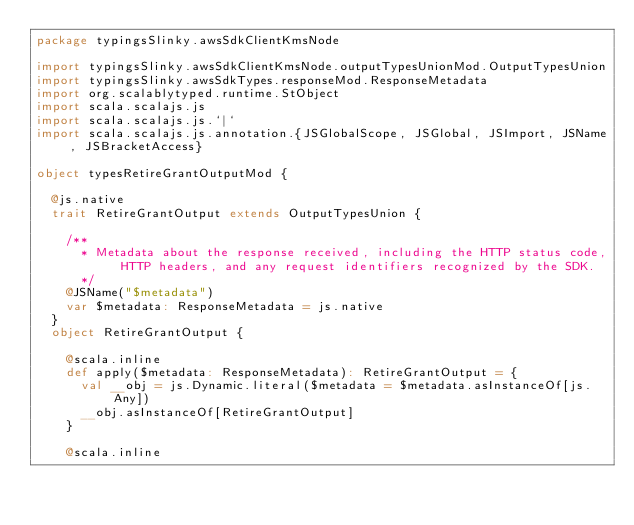<code> <loc_0><loc_0><loc_500><loc_500><_Scala_>package typingsSlinky.awsSdkClientKmsNode

import typingsSlinky.awsSdkClientKmsNode.outputTypesUnionMod.OutputTypesUnion
import typingsSlinky.awsSdkTypes.responseMod.ResponseMetadata
import org.scalablytyped.runtime.StObject
import scala.scalajs.js
import scala.scalajs.js.`|`
import scala.scalajs.js.annotation.{JSGlobalScope, JSGlobal, JSImport, JSName, JSBracketAccess}

object typesRetireGrantOutputMod {
  
  @js.native
  trait RetireGrantOutput extends OutputTypesUnion {
    
    /**
      * Metadata about the response received, including the HTTP status code, HTTP headers, and any request identifiers recognized by the SDK.
      */
    @JSName("$metadata")
    var $metadata: ResponseMetadata = js.native
  }
  object RetireGrantOutput {
    
    @scala.inline
    def apply($metadata: ResponseMetadata): RetireGrantOutput = {
      val __obj = js.Dynamic.literal($metadata = $metadata.asInstanceOf[js.Any])
      __obj.asInstanceOf[RetireGrantOutput]
    }
    
    @scala.inline</code> 